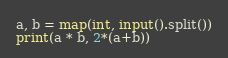Convert code to text. <code><loc_0><loc_0><loc_500><loc_500><_Python_>a, b = map(int, input().split())
print(a * b, 2*(a+b))</code> 